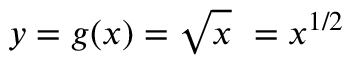Convert formula to latex. <formula><loc_0><loc_0><loc_500><loc_500>y = g ( x ) = { \sqrt { x } } \ = x ^ { 1 / 2 }</formula> 